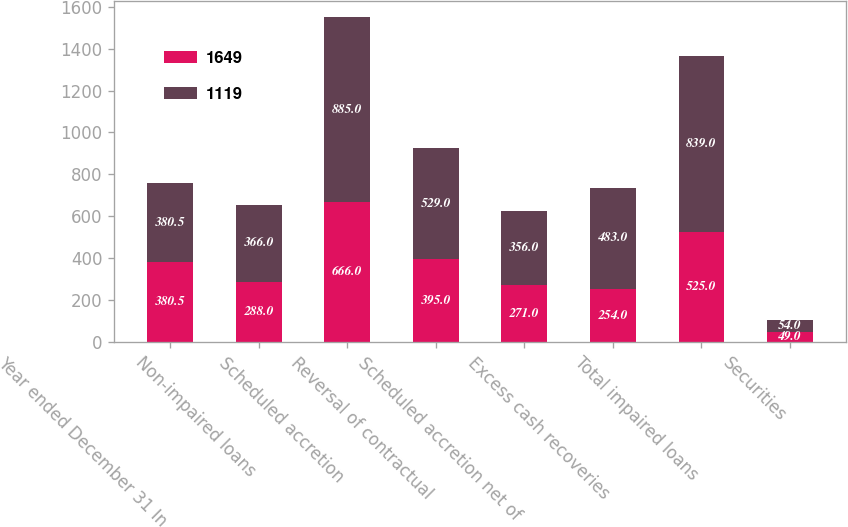Convert chart to OTSL. <chart><loc_0><loc_0><loc_500><loc_500><stacked_bar_chart><ecel><fcel>Year ended December 31 In<fcel>Non-impaired loans<fcel>Scheduled accretion<fcel>Reversal of contractual<fcel>Scheduled accretion net of<fcel>Excess cash recoveries<fcel>Total impaired loans<fcel>Securities<nl><fcel>1649<fcel>380.5<fcel>288<fcel>666<fcel>395<fcel>271<fcel>254<fcel>525<fcel>49<nl><fcel>1119<fcel>380.5<fcel>366<fcel>885<fcel>529<fcel>356<fcel>483<fcel>839<fcel>54<nl></chart> 